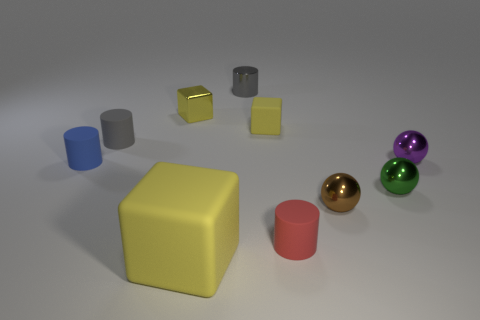How many other things are there of the same material as the green object? Including the green object, there are a total of five items that appear to be made of the same glossy material in the image, suggesting these items share similar properties such as reflectiveness and smooth texture. 